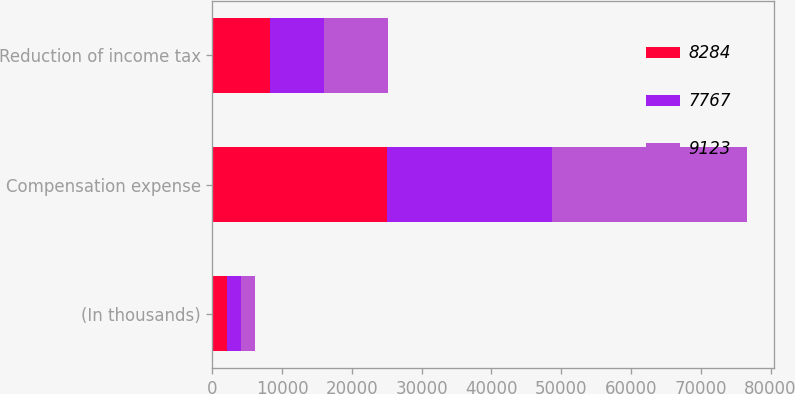<chart> <loc_0><loc_0><loc_500><loc_500><stacked_bar_chart><ecel><fcel>(In thousands)<fcel>Compensation expense<fcel>Reduction of income tax<nl><fcel>8284<fcel>2015<fcel>24974<fcel>8284<nl><fcel>7767<fcel>2014<fcel>23632<fcel>7767<nl><fcel>9123<fcel>2013<fcel>28052<fcel>9123<nl></chart> 